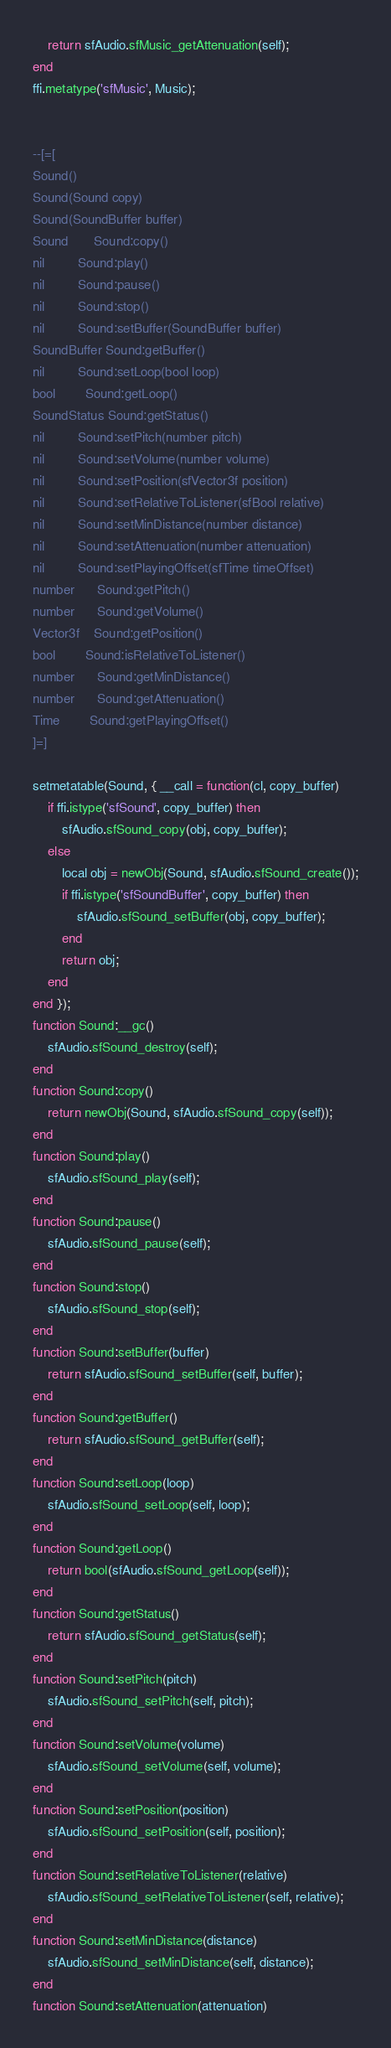<code> <loc_0><loc_0><loc_500><loc_500><_Lua_>	return sfAudio.sfMusic_getAttenuation(self);
end
ffi.metatype('sfMusic', Music);


--[=[
Sound()
Sound(Sound copy)
Sound(SoundBuffer buffer)
Sound       Sound:copy()
nil         Sound:play()
nil         Sound:pause()
nil         Sound:stop()
nil         Sound:setBuffer(SoundBuffer buffer)
SoundBuffer Sound:getBuffer()
nil         Sound:setLoop(bool loop)
bool        Sound:getLoop()
SoundStatus Sound:getStatus()
nil         Sound:setPitch(number pitch)
nil         Sound:setVolume(number volume)
nil         Sound:setPosition(sfVector3f position)
nil         Sound:setRelativeToListener(sfBool relative)
nil         Sound:setMinDistance(number distance)
nil         Sound:setAttenuation(number attenuation)
nil         Sound:setPlayingOffset(sfTime timeOffset)
number      Sound:getPitch()
number      Sound:getVolume()
Vector3f    Sound:getPosition()
bool        Sound:isRelativeToListener()
number      Sound:getMinDistance()
number      Sound:getAttenuation()
Time        Sound:getPlayingOffset()
]=]

setmetatable(Sound, { __call = function(cl, copy_buffer)
	if ffi.istype('sfSound', copy_buffer) then
		sfAudio.sfSound_copy(obj, copy_buffer);
	else
		local obj = newObj(Sound, sfAudio.sfSound_create());
		if ffi.istype('sfSoundBuffer', copy_buffer) then
			sfAudio.sfSound_setBuffer(obj, copy_buffer);
		end
		return obj;
	end
end });
function Sound:__gc()
	sfAudio.sfSound_destroy(self);
end
function Sound:copy()
	return newObj(Sound, sfAudio.sfSound_copy(self));
end
function Sound:play()
	sfAudio.sfSound_play(self);
end
function Sound:pause()
	sfAudio.sfSound_pause(self);
end
function Sound:stop()
	sfAudio.sfSound_stop(self);
end
function Sound:setBuffer(buffer)
	return sfAudio.sfSound_setBuffer(self, buffer);
end
function Sound:getBuffer()
	return sfAudio.sfSound_getBuffer(self);
end
function Sound:setLoop(loop)
	sfAudio.sfSound_setLoop(self, loop);
end
function Sound:getLoop()
	return bool(sfAudio.sfSound_getLoop(self));
end
function Sound:getStatus()
	return sfAudio.sfSound_getStatus(self);
end
function Sound:setPitch(pitch)
	sfAudio.sfSound_setPitch(self, pitch);
end
function Sound:setVolume(volume)
	sfAudio.sfSound_setVolume(self, volume);
end
function Sound:setPosition(position)
	sfAudio.sfSound_setPosition(self, position);
end
function Sound:setRelativeToListener(relative)
	sfAudio.sfSound_setRelativeToListener(self, relative);
end
function Sound:setMinDistance(distance)
	sfAudio.sfSound_setMinDistance(self, distance);
end
function Sound:setAttenuation(attenuation)</code> 